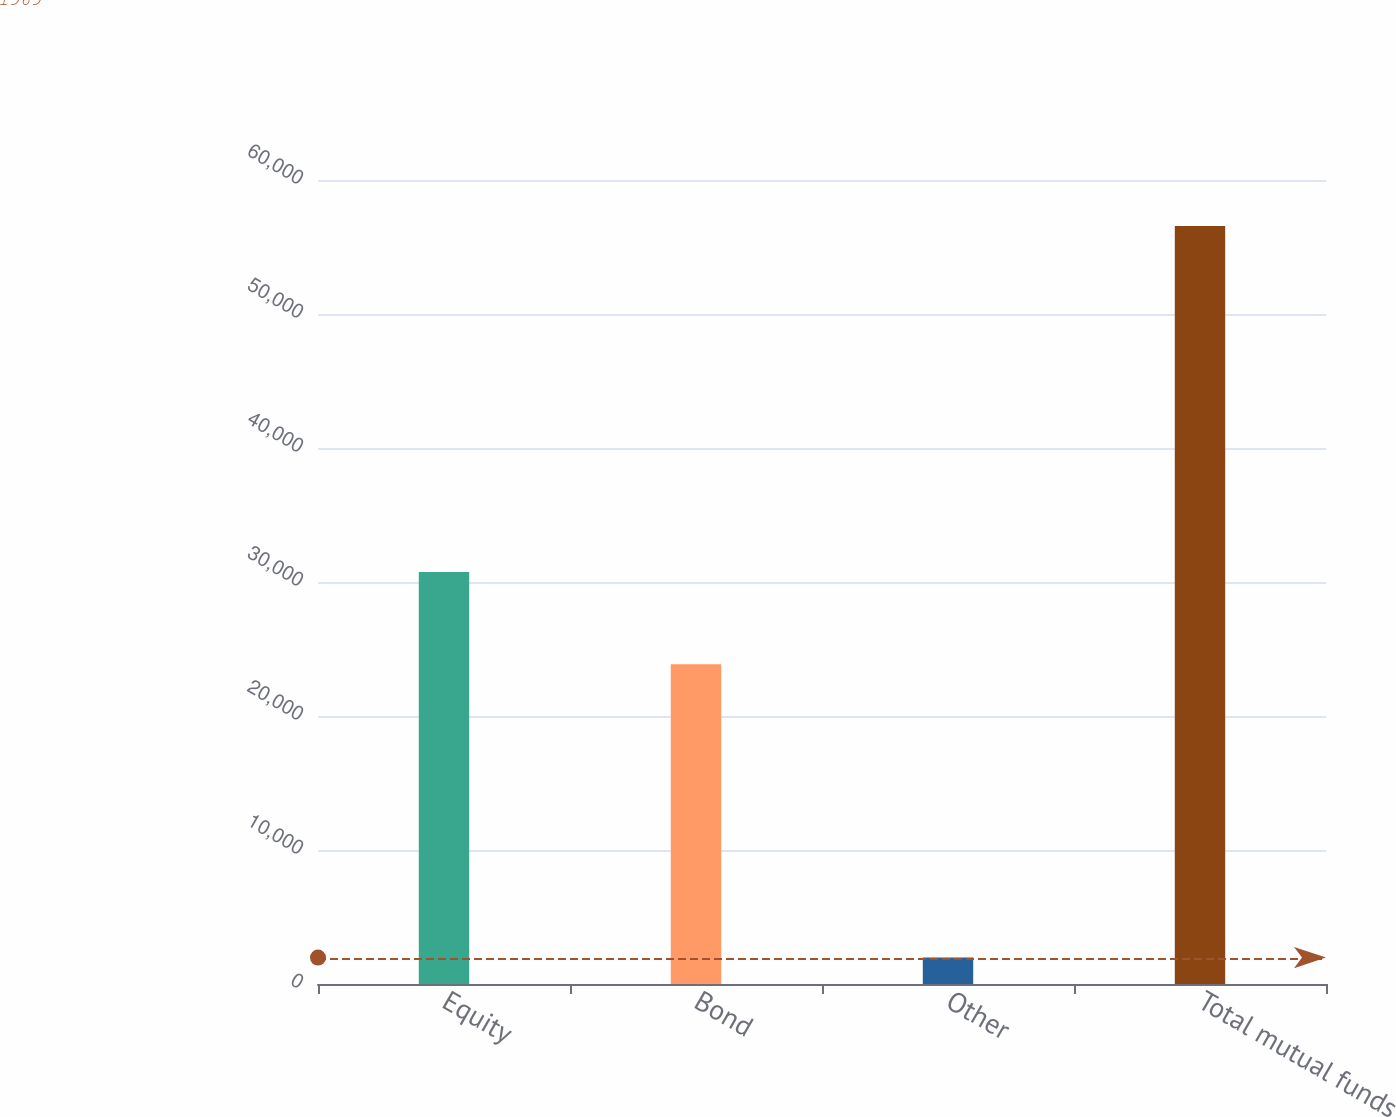Convert chart. <chart><loc_0><loc_0><loc_500><loc_500><bar_chart><fcel>Equity<fcel>Bond<fcel>Other<fcel>Total mutual funds<nl><fcel>30738<fcel>23862<fcel>1969<fcel>56569<nl></chart> 